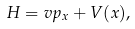Convert formula to latex. <formula><loc_0><loc_0><loc_500><loc_500>H = v p _ { x } + V ( x ) ,</formula> 